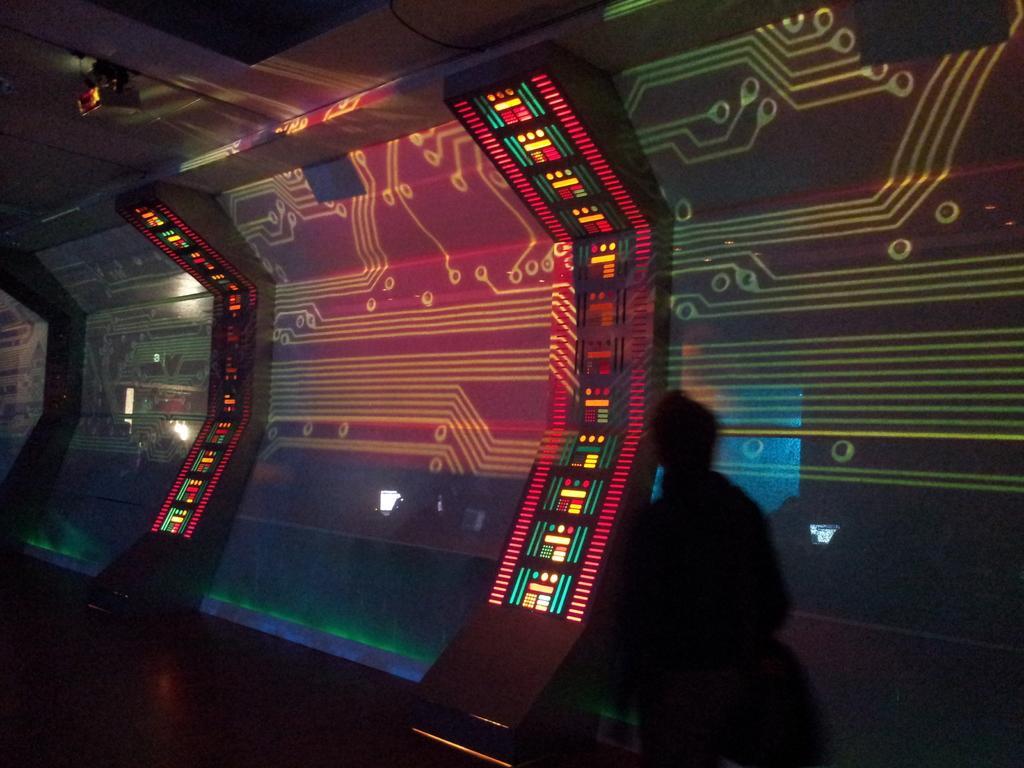How would you summarize this image in a sentence or two? In this image there is a person in the foreground. There is a screen in the background. There is a floor at the bottom. And there is a light on roof at the top. 